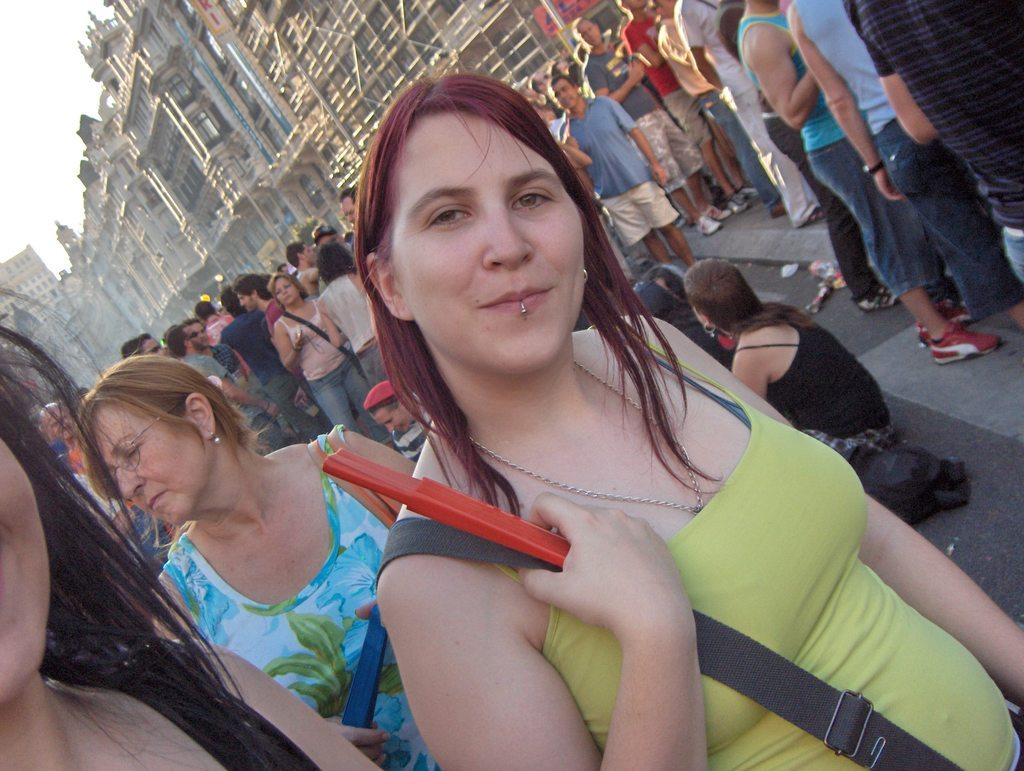How many people are in the foreground of the image? There are many people in the foreground of the image. What can be seen in the background of the image? There are buildings visible in the background of the image. What type of bat is flying around the people in the image? There is no bat present in the image. Who is the minister in the image? There is no minister present in the image. 